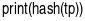<code> <loc_0><loc_0><loc_500><loc_500><_Python_>print(hash(tp))
</code> 